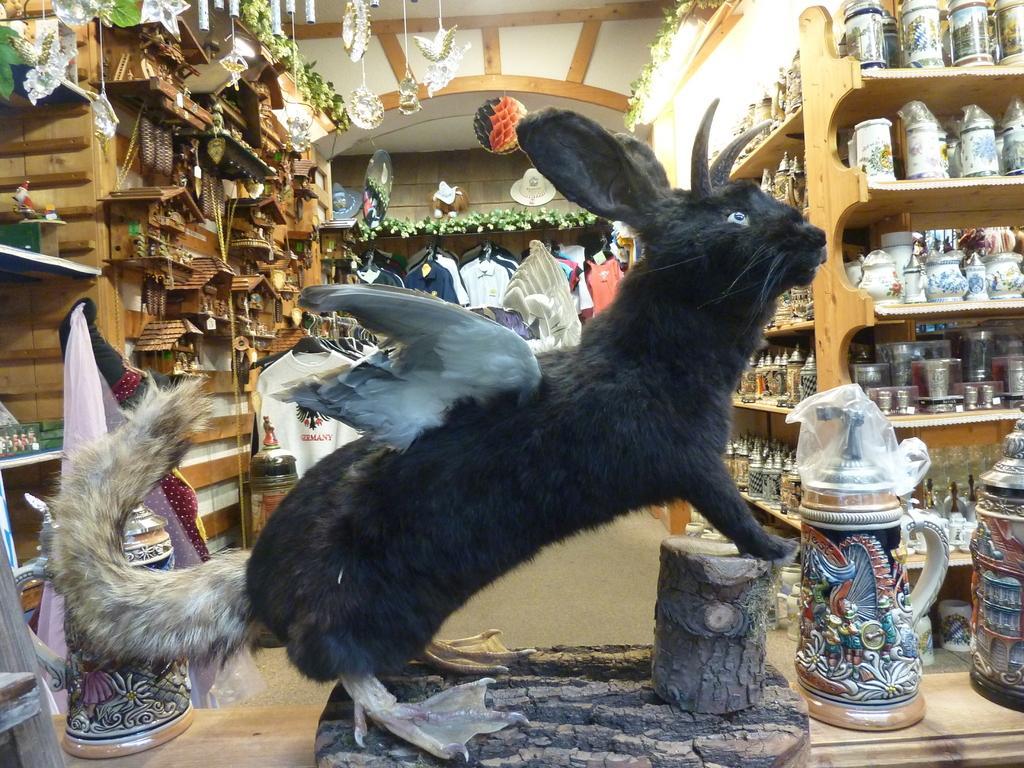Can you describe this image briefly? In this image there is a wooden table in the foreground. On the table there are jars and a sculpture of an animal. Behind it there are wooden racks. To the right there are jars and glasses in the rack. To the left there are small house toys in the rack. In the background there are clothes to the hangers. At the top there are decorative things hanging to the ceiling. 